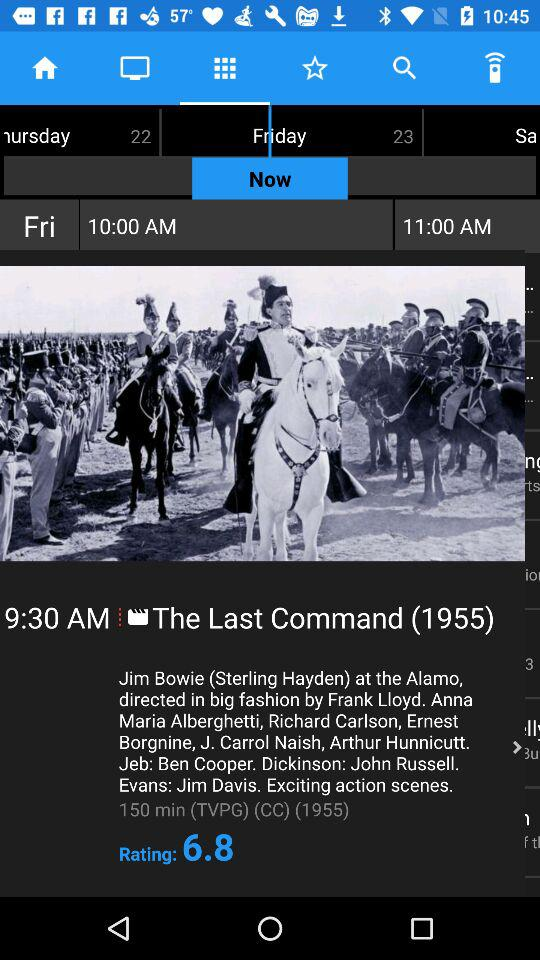What is the name of the movie? The name of the movie is "The Last Command (1955)". 